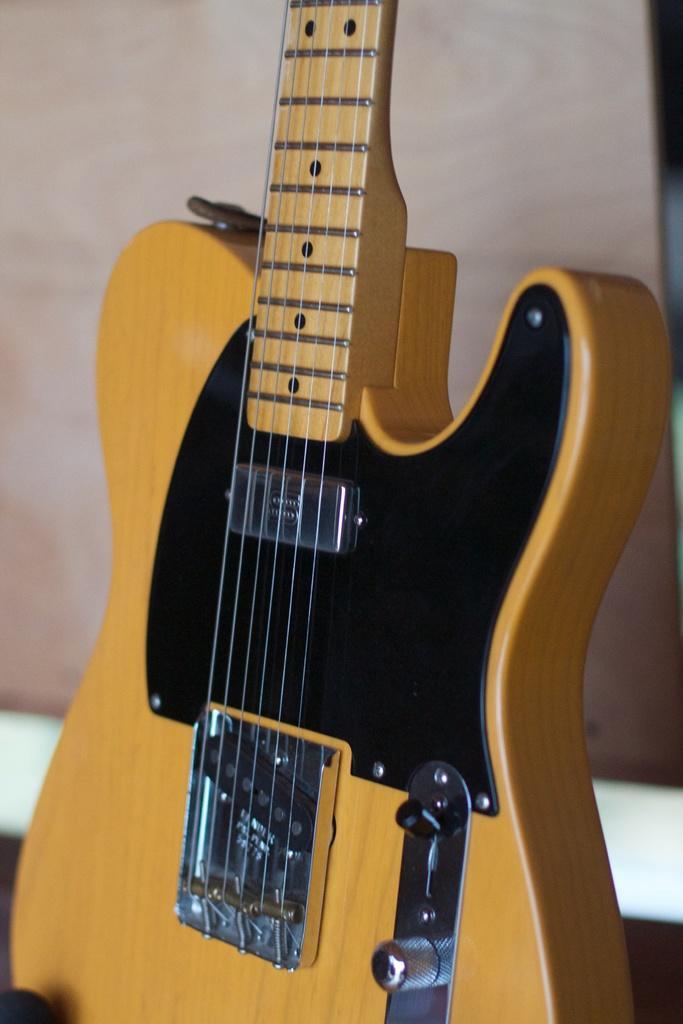Could you give a brief overview of what you see in this image? This picture shows a guitar with the strings which is yellow in color. In the background there is a wall. 